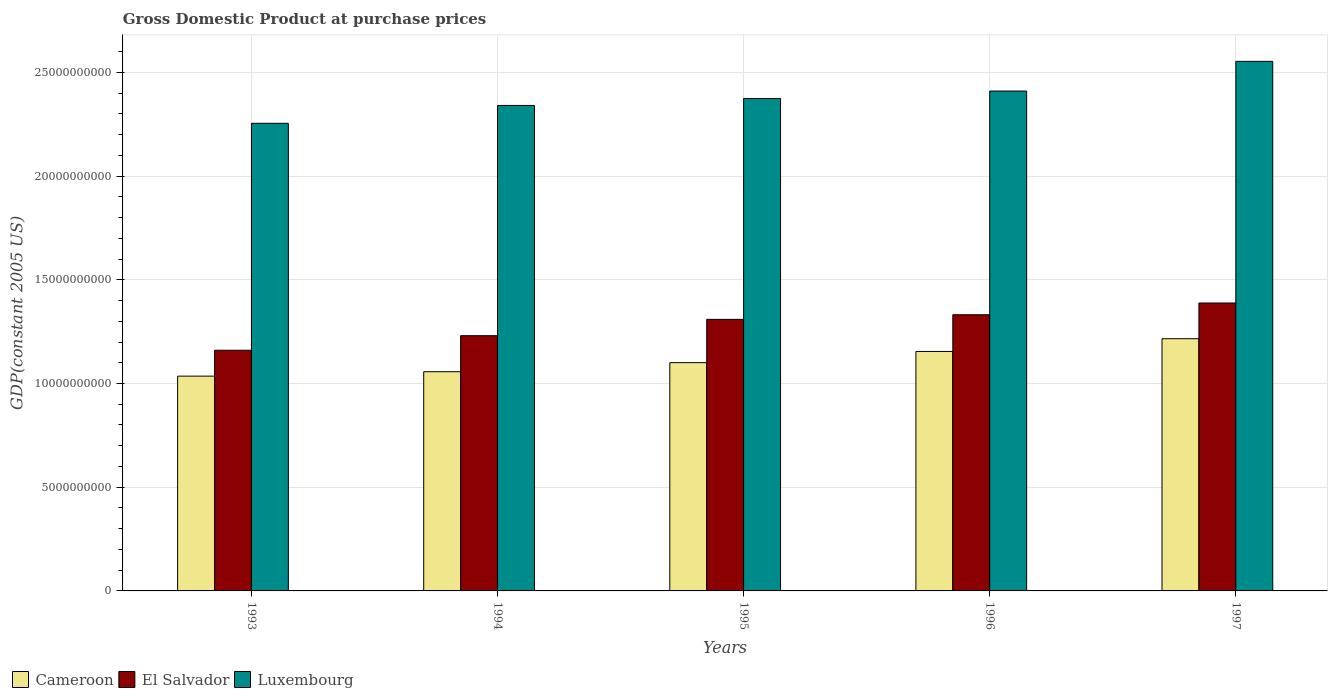How many different coloured bars are there?
Your response must be concise. 3. How many bars are there on the 1st tick from the left?
Offer a very short reply. 3. In how many cases, is the number of bars for a given year not equal to the number of legend labels?
Keep it short and to the point. 0. What is the GDP at purchase prices in Luxembourg in 1997?
Provide a succinct answer. 2.55e+1. Across all years, what is the maximum GDP at purchase prices in Cameroon?
Your response must be concise. 1.22e+1. Across all years, what is the minimum GDP at purchase prices in Luxembourg?
Ensure brevity in your answer.  2.25e+1. In which year was the GDP at purchase prices in Cameroon minimum?
Provide a short and direct response. 1993. What is the total GDP at purchase prices in El Salvador in the graph?
Make the answer very short. 6.42e+1. What is the difference between the GDP at purchase prices in Luxembourg in 1993 and that in 1996?
Keep it short and to the point. -1.56e+09. What is the difference between the GDP at purchase prices in El Salvador in 1993 and the GDP at purchase prices in Cameroon in 1997?
Your answer should be compact. -5.56e+08. What is the average GDP at purchase prices in El Salvador per year?
Provide a short and direct response. 1.28e+1. In the year 1997, what is the difference between the GDP at purchase prices in El Salvador and GDP at purchase prices in Cameroon?
Keep it short and to the point. 1.72e+09. What is the ratio of the GDP at purchase prices in El Salvador in 1995 to that in 1997?
Your answer should be compact. 0.94. What is the difference between the highest and the second highest GDP at purchase prices in Cameroon?
Provide a succinct answer. 6.14e+08. What is the difference between the highest and the lowest GDP at purchase prices in El Salvador?
Your answer should be compact. 2.28e+09. Is the sum of the GDP at purchase prices in Luxembourg in 1995 and 1997 greater than the maximum GDP at purchase prices in Cameroon across all years?
Provide a short and direct response. Yes. What does the 3rd bar from the left in 1997 represents?
Give a very brief answer. Luxembourg. What does the 3rd bar from the right in 1995 represents?
Provide a short and direct response. Cameroon. Is it the case that in every year, the sum of the GDP at purchase prices in Luxembourg and GDP at purchase prices in Cameroon is greater than the GDP at purchase prices in El Salvador?
Provide a short and direct response. Yes. How many bars are there?
Keep it short and to the point. 15. Does the graph contain grids?
Your answer should be compact. Yes. How many legend labels are there?
Your answer should be compact. 3. How are the legend labels stacked?
Give a very brief answer. Horizontal. What is the title of the graph?
Your response must be concise. Gross Domestic Product at purchase prices. Does "Croatia" appear as one of the legend labels in the graph?
Your answer should be compact. No. What is the label or title of the X-axis?
Offer a terse response. Years. What is the label or title of the Y-axis?
Give a very brief answer. GDP(constant 2005 US). What is the GDP(constant 2005 US) of Cameroon in 1993?
Offer a terse response. 1.04e+1. What is the GDP(constant 2005 US) of El Salvador in 1993?
Keep it short and to the point. 1.16e+1. What is the GDP(constant 2005 US) of Luxembourg in 1993?
Ensure brevity in your answer.  2.25e+1. What is the GDP(constant 2005 US) in Cameroon in 1994?
Your answer should be very brief. 1.06e+1. What is the GDP(constant 2005 US) of El Salvador in 1994?
Your response must be concise. 1.23e+1. What is the GDP(constant 2005 US) of Luxembourg in 1994?
Ensure brevity in your answer.  2.34e+1. What is the GDP(constant 2005 US) in Cameroon in 1995?
Keep it short and to the point. 1.10e+1. What is the GDP(constant 2005 US) in El Salvador in 1995?
Keep it short and to the point. 1.31e+1. What is the GDP(constant 2005 US) in Luxembourg in 1995?
Ensure brevity in your answer.  2.37e+1. What is the GDP(constant 2005 US) of Cameroon in 1996?
Provide a succinct answer. 1.15e+1. What is the GDP(constant 2005 US) in El Salvador in 1996?
Give a very brief answer. 1.33e+1. What is the GDP(constant 2005 US) in Luxembourg in 1996?
Your answer should be very brief. 2.41e+1. What is the GDP(constant 2005 US) in Cameroon in 1997?
Give a very brief answer. 1.22e+1. What is the GDP(constant 2005 US) in El Salvador in 1997?
Ensure brevity in your answer.  1.39e+1. What is the GDP(constant 2005 US) in Luxembourg in 1997?
Provide a succinct answer. 2.55e+1. Across all years, what is the maximum GDP(constant 2005 US) of Cameroon?
Keep it short and to the point. 1.22e+1. Across all years, what is the maximum GDP(constant 2005 US) of El Salvador?
Provide a short and direct response. 1.39e+1. Across all years, what is the maximum GDP(constant 2005 US) of Luxembourg?
Offer a very short reply. 2.55e+1. Across all years, what is the minimum GDP(constant 2005 US) of Cameroon?
Your answer should be compact. 1.04e+1. Across all years, what is the minimum GDP(constant 2005 US) in El Salvador?
Offer a very short reply. 1.16e+1. Across all years, what is the minimum GDP(constant 2005 US) in Luxembourg?
Offer a terse response. 2.25e+1. What is the total GDP(constant 2005 US) in Cameroon in the graph?
Your answer should be compact. 5.56e+1. What is the total GDP(constant 2005 US) in El Salvador in the graph?
Your response must be concise. 6.42e+1. What is the total GDP(constant 2005 US) in Luxembourg in the graph?
Provide a succinct answer. 1.19e+11. What is the difference between the GDP(constant 2005 US) of Cameroon in 1993 and that in 1994?
Offer a terse response. -2.14e+08. What is the difference between the GDP(constant 2005 US) in El Salvador in 1993 and that in 1994?
Offer a very short reply. -7.02e+08. What is the difference between the GDP(constant 2005 US) of Luxembourg in 1993 and that in 1994?
Provide a short and direct response. -8.61e+08. What is the difference between the GDP(constant 2005 US) of Cameroon in 1993 and that in 1995?
Offer a terse response. -6.50e+08. What is the difference between the GDP(constant 2005 US) in El Salvador in 1993 and that in 1995?
Offer a terse response. -1.49e+09. What is the difference between the GDP(constant 2005 US) of Luxembourg in 1993 and that in 1995?
Your response must be concise. -1.20e+09. What is the difference between the GDP(constant 2005 US) of Cameroon in 1993 and that in 1996?
Keep it short and to the point. -1.19e+09. What is the difference between the GDP(constant 2005 US) of El Salvador in 1993 and that in 1996?
Offer a very short reply. -1.71e+09. What is the difference between the GDP(constant 2005 US) of Luxembourg in 1993 and that in 1996?
Offer a very short reply. -1.56e+09. What is the difference between the GDP(constant 2005 US) of Cameroon in 1993 and that in 1997?
Your answer should be compact. -1.80e+09. What is the difference between the GDP(constant 2005 US) in El Salvador in 1993 and that in 1997?
Your response must be concise. -2.28e+09. What is the difference between the GDP(constant 2005 US) in Luxembourg in 1993 and that in 1997?
Provide a succinct answer. -2.99e+09. What is the difference between the GDP(constant 2005 US) in Cameroon in 1994 and that in 1995?
Ensure brevity in your answer.  -4.36e+08. What is the difference between the GDP(constant 2005 US) in El Salvador in 1994 and that in 1995?
Your answer should be compact. -7.87e+08. What is the difference between the GDP(constant 2005 US) in Luxembourg in 1994 and that in 1995?
Ensure brevity in your answer.  -3.35e+08. What is the difference between the GDP(constant 2005 US) in Cameroon in 1994 and that in 1996?
Keep it short and to the point. -9.77e+08. What is the difference between the GDP(constant 2005 US) in El Salvador in 1994 and that in 1996?
Keep it short and to the point. -1.01e+09. What is the difference between the GDP(constant 2005 US) in Luxembourg in 1994 and that in 1996?
Provide a short and direct response. -6.95e+08. What is the difference between the GDP(constant 2005 US) in Cameroon in 1994 and that in 1997?
Offer a very short reply. -1.59e+09. What is the difference between the GDP(constant 2005 US) of El Salvador in 1994 and that in 1997?
Offer a terse response. -1.58e+09. What is the difference between the GDP(constant 2005 US) of Luxembourg in 1994 and that in 1997?
Offer a terse response. -2.13e+09. What is the difference between the GDP(constant 2005 US) in Cameroon in 1995 and that in 1996?
Your response must be concise. -5.41e+08. What is the difference between the GDP(constant 2005 US) in El Salvador in 1995 and that in 1996?
Offer a very short reply. -2.23e+08. What is the difference between the GDP(constant 2005 US) of Luxembourg in 1995 and that in 1996?
Your answer should be very brief. -3.60e+08. What is the difference between the GDP(constant 2005 US) of Cameroon in 1995 and that in 1997?
Provide a short and direct response. -1.15e+09. What is the difference between the GDP(constant 2005 US) of El Salvador in 1995 and that in 1997?
Provide a short and direct response. -7.89e+08. What is the difference between the GDP(constant 2005 US) of Luxembourg in 1995 and that in 1997?
Your answer should be very brief. -1.79e+09. What is the difference between the GDP(constant 2005 US) in Cameroon in 1996 and that in 1997?
Offer a very short reply. -6.14e+08. What is the difference between the GDP(constant 2005 US) of El Salvador in 1996 and that in 1997?
Your answer should be very brief. -5.65e+08. What is the difference between the GDP(constant 2005 US) of Luxembourg in 1996 and that in 1997?
Provide a succinct answer. -1.43e+09. What is the difference between the GDP(constant 2005 US) of Cameroon in 1993 and the GDP(constant 2005 US) of El Salvador in 1994?
Offer a very short reply. -1.95e+09. What is the difference between the GDP(constant 2005 US) in Cameroon in 1993 and the GDP(constant 2005 US) in Luxembourg in 1994?
Your answer should be compact. -1.31e+1. What is the difference between the GDP(constant 2005 US) of El Salvador in 1993 and the GDP(constant 2005 US) of Luxembourg in 1994?
Your answer should be compact. -1.18e+1. What is the difference between the GDP(constant 2005 US) in Cameroon in 1993 and the GDP(constant 2005 US) in El Salvador in 1995?
Your answer should be compact. -2.74e+09. What is the difference between the GDP(constant 2005 US) of Cameroon in 1993 and the GDP(constant 2005 US) of Luxembourg in 1995?
Ensure brevity in your answer.  -1.34e+1. What is the difference between the GDP(constant 2005 US) of El Salvador in 1993 and the GDP(constant 2005 US) of Luxembourg in 1995?
Your response must be concise. -1.21e+1. What is the difference between the GDP(constant 2005 US) of Cameroon in 1993 and the GDP(constant 2005 US) of El Salvador in 1996?
Your answer should be compact. -2.96e+09. What is the difference between the GDP(constant 2005 US) of Cameroon in 1993 and the GDP(constant 2005 US) of Luxembourg in 1996?
Provide a short and direct response. -1.37e+1. What is the difference between the GDP(constant 2005 US) in El Salvador in 1993 and the GDP(constant 2005 US) in Luxembourg in 1996?
Ensure brevity in your answer.  -1.25e+1. What is the difference between the GDP(constant 2005 US) in Cameroon in 1993 and the GDP(constant 2005 US) in El Salvador in 1997?
Keep it short and to the point. -3.53e+09. What is the difference between the GDP(constant 2005 US) in Cameroon in 1993 and the GDP(constant 2005 US) in Luxembourg in 1997?
Your response must be concise. -1.52e+1. What is the difference between the GDP(constant 2005 US) of El Salvador in 1993 and the GDP(constant 2005 US) of Luxembourg in 1997?
Offer a terse response. -1.39e+1. What is the difference between the GDP(constant 2005 US) in Cameroon in 1994 and the GDP(constant 2005 US) in El Salvador in 1995?
Your answer should be very brief. -2.52e+09. What is the difference between the GDP(constant 2005 US) in Cameroon in 1994 and the GDP(constant 2005 US) in Luxembourg in 1995?
Keep it short and to the point. -1.32e+1. What is the difference between the GDP(constant 2005 US) in El Salvador in 1994 and the GDP(constant 2005 US) in Luxembourg in 1995?
Your answer should be very brief. -1.14e+1. What is the difference between the GDP(constant 2005 US) of Cameroon in 1994 and the GDP(constant 2005 US) of El Salvador in 1996?
Your answer should be very brief. -2.75e+09. What is the difference between the GDP(constant 2005 US) in Cameroon in 1994 and the GDP(constant 2005 US) in Luxembourg in 1996?
Provide a succinct answer. -1.35e+1. What is the difference between the GDP(constant 2005 US) in El Salvador in 1994 and the GDP(constant 2005 US) in Luxembourg in 1996?
Make the answer very short. -1.18e+1. What is the difference between the GDP(constant 2005 US) in Cameroon in 1994 and the GDP(constant 2005 US) in El Salvador in 1997?
Make the answer very short. -3.31e+09. What is the difference between the GDP(constant 2005 US) of Cameroon in 1994 and the GDP(constant 2005 US) of Luxembourg in 1997?
Ensure brevity in your answer.  -1.50e+1. What is the difference between the GDP(constant 2005 US) in El Salvador in 1994 and the GDP(constant 2005 US) in Luxembourg in 1997?
Ensure brevity in your answer.  -1.32e+1. What is the difference between the GDP(constant 2005 US) in Cameroon in 1995 and the GDP(constant 2005 US) in El Salvador in 1996?
Give a very brief answer. -2.31e+09. What is the difference between the GDP(constant 2005 US) of Cameroon in 1995 and the GDP(constant 2005 US) of Luxembourg in 1996?
Your answer should be compact. -1.31e+1. What is the difference between the GDP(constant 2005 US) in El Salvador in 1995 and the GDP(constant 2005 US) in Luxembourg in 1996?
Your response must be concise. -1.10e+1. What is the difference between the GDP(constant 2005 US) in Cameroon in 1995 and the GDP(constant 2005 US) in El Salvador in 1997?
Provide a succinct answer. -2.88e+09. What is the difference between the GDP(constant 2005 US) in Cameroon in 1995 and the GDP(constant 2005 US) in Luxembourg in 1997?
Offer a terse response. -1.45e+1. What is the difference between the GDP(constant 2005 US) of El Salvador in 1995 and the GDP(constant 2005 US) of Luxembourg in 1997?
Keep it short and to the point. -1.24e+1. What is the difference between the GDP(constant 2005 US) in Cameroon in 1996 and the GDP(constant 2005 US) in El Salvador in 1997?
Offer a very short reply. -2.34e+09. What is the difference between the GDP(constant 2005 US) in Cameroon in 1996 and the GDP(constant 2005 US) in Luxembourg in 1997?
Ensure brevity in your answer.  -1.40e+1. What is the difference between the GDP(constant 2005 US) in El Salvador in 1996 and the GDP(constant 2005 US) in Luxembourg in 1997?
Your answer should be very brief. -1.22e+1. What is the average GDP(constant 2005 US) of Cameroon per year?
Ensure brevity in your answer.  1.11e+1. What is the average GDP(constant 2005 US) in El Salvador per year?
Your response must be concise. 1.28e+1. What is the average GDP(constant 2005 US) in Luxembourg per year?
Provide a succinct answer. 2.39e+1. In the year 1993, what is the difference between the GDP(constant 2005 US) in Cameroon and GDP(constant 2005 US) in El Salvador?
Provide a short and direct response. -1.25e+09. In the year 1993, what is the difference between the GDP(constant 2005 US) in Cameroon and GDP(constant 2005 US) in Luxembourg?
Your answer should be very brief. -1.22e+1. In the year 1993, what is the difference between the GDP(constant 2005 US) in El Salvador and GDP(constant 2005 US) in Luxembourg?
Your answer should be very brief. -1.09e+1. In the year 1994, what is the difference between the GDP(constant 2005 US) in Cameroon and GDP(constant 2005 US) in El Salvador?
Provide a short and direct response. -1.74e+09. In the year 1994, what is the difference between the GDP(constant 2005 US) of Cameroon and GDP(constant 2005 US) of Luxembourg?
Your answer should be very brief. -1.28e+1. In the year 1994, what is the difference between the GDP(constant 2005 US) of El Salvador and GDP(constant 2005 US) of Luxembourg?
Your answer should be compact. -1.11e+1. In the year 1995, what is the difference between the GDP(constant 2005 US) of Cameroon and GDP(constant 2005 US) of El Salvador?
Keep it short and to the point. -2.09e+09. In the year 1995, what is the difference between the GDP(constant 2005 US) of Cameroon and GDP(constant 2005 US) of Luxembourg?
Ensure brevity in your answer.  -1.27e+1. In the year 1995, what is the difference between the GDP(constant 2005 US) in El Salvador and GDP(constant 2005 US) in Luxembourg?
Offer a very short reply. -1.06e+1. In the year 1996, what is the difference between the GDP(constant 2005 US) in Cameroon and GDP(constant 2005 US) in El Salvador?
Offer a terse response. -1.77e+09. In the year 1996, what is the difference between the GDP(constant 2005 US) in Cameroon and GDP(constant 2005 US) in Luxembourg?
Offer a terse response. -1.26e+1. In the year 1996, what is the difference between the GDP(constant 2005 US) of El Salvador and GDP(constant 2005 US) of Luxembourg?
Your answer should be compact. -1.08e+1. In the year 1997, what is the difference between the GDP(constant 2005 US) of Cameroon and GDP(constant 2005 US) of El Salvador?
Offer a very short reply. -1.72e+09. In the year 1997, what is the difference between the GDP(constant 2005 US) of Cameroon and GDP(constant 2005 US) of Luxembourg?
Your response must be concise. -1.34e+1. In the year 1997, what is the difference between the GDP(constant 2005 US) in El Salvador and GDP(constant 2005 US) in Luxembourg?
Offer a very short reply. -1.17e+1. What is the ratio of the GDP(constant 2005 US) of Cameroon in 1993 to that in 1994?
Offer a terse response. 0.98. What is the ratio of the GDP(constant 2005 US) in El Salvador in 1993 to that in 1994?
Give a very brief answer. 0.94. What is the ratio of the GDP(constant 2005 US) of Luxembourg in 1993 to that in 1994?
Give a very brief answer. 0.96. What is the ratio of the GDP(constant 2005 US) of Cameroon in 1993 to that in 1995?
Ensure brevity in your answer.  0.94. What is the ratio of the GDP(constant 2005 US) of El Salvador in 1993 to that in 1995?
Offer a terse response. 0.89. What is the ratio of the GDP(constant 2005 US) of Luxembourg in 1993 to that in 1995?
Keep it short and to the point. 0.95. What is the ratio of the GDP(constant 2005 US) of Cameroon in 1993 to that in 1996?
Keep it short and to the point. 0.9. What is the ratio of the GDP(constant 2005 US) of El Salvador in 1993 to that in 1996?
Offer a terse response. 0.87. What is the ratio of the GDP(constant 2005 US) of Luxembourg in 1993 to that in 1996?
Keep it short and to the point. 0.94. What is the ratio of the GDP(constant 2005 US) of Cameroon in 1993 to that in 1997?
Provide a short and direct response. 0.85. What is the ratio of the GDP(constant 2005 US) in El Salvador in 1993 to that in 1997?
Provide a short and direct response. 0.84. What is the ratio of the GDP(constant 2005 US) in Luxembourg in 1993 to that in 1997?
Your answer should be compact. 0.88. What is the ratio of the GDP(constant 2005 US) of Cameroon in 1994 to that in 1995?
Provide a succinct answer. 0.96. What is the ratio of the GDP(constant 2005 US) in El Salvador in 1994 to that in 1995?
Keep it short and to the point. 0.94. What is the ratio of the GDP(constant 2005 US) in Luxembourg in 1994 to that in 1995?
Offer a terse response. 0.99. What is the ratio of the GDP(constant 2005 US) in Cameroon in 1994 to that in 1996?
Keep it short and to the point. 0.92. What is the ratio of the GDP(constant 2005 US) in El Salvador in 1994 to that in 1996?
Your response must be concise. 0.92. What is the ratio of the GDP(constant 2005 US) of Luxembourg in 1994 to that in 1996?
Your response must be concise. 0.97. What is the ratio of the GDP(constant 2005 US) of Cameroon in 1994 to that in 1997?
Keep it short and to the point. 0.87. What is the ratio of the GDP(constant 2005 US) in El Salvador in 1994 to that in 1997?
Provide a short and direct response. 0.89. What is the ratio of the GDP(constant 2005 US) of Luxembourg in 1994 to that in 1997?
Offer a terse response. 0.92. What is the ratio of the GDP(constant 2005 US) in Cameroon in 1995 to that in 1996?
Provide a succinct answer. 0.95. What is the ratio of the GDP(constant 2005 US) of El Salvador in 1995 to that in 1996?
Offer a very short reply. 0.98. What is the ratio of the GDP(constant 2005 US) in Luxembourg in 1995 to that in 1996?
Your answer should be very brief. 0.99. What is the ratio of the GDP(constant 2005 US) of Cameroon in 1995 to that in 1997?
Your answer should be compact. 0.91. What is the ratio of the GDP(constant 2005 US) of El Salvador in 1995 to that in 1997?
Offer a terse response. 0.94. What is the ratio of the GDP(constant 2005 US) of Luxembourg in 1995 to that in 1997?
Offer a very short reply. 0.93. What is the ratio of the GDP(constant 2005 US) in Cameroon in 1996 to that in 1997?
Provide a short and direct response. 0.95. What is the ratio of the GDP(constant 2005 US) of El Salvador in 1996 to that in 1997?
Ensure brevity in your answer.  0.96. What is the ratio of the GDP(constant 2005 US) of Luxembourg in 1996 to that in 1997?
Provide a succinct answer. 0.94. What is the difference between the highest and the second highest GDP(constant 2005 US) of Cameroon?
Provide a short and direct response. 6.14e+08. What is the difference between the highest and the second highest GDP(constant 2005 US) of El Salvador?
Ensure brevity in your answer.  5.65e+08. What is the difference between the highest and the second highest GDP(constant 2005 US) in Luxembourg?
Keep it short and to the point. 1.43e+09. What is the difference between the highest and the lowest GDP(constant 2005 US) of Cameroon?
Keep it short and to the point. 1.80e+09. What is the difference between the highest and the lowest GDP(constant 2005 US) of El Salvador?
Offer a terse response. 2.28e+09. What is the difference between the highest and the lowest GDP(constant 2005 US) of Luxembourg?
Provide a succinct answer. 2.99e+09. 